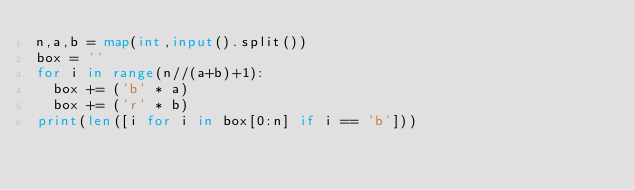<code> <loc_0><loc_0><loc_500><loc_500><_Python_>n,a,b = map(int,input().split())
box = ''
for i in range(n//(a+b)+1):
  box += ('b' * a)
  box += ('r' * b)
print(len([i for i in box[0:n] if i == 'b']))</code> 